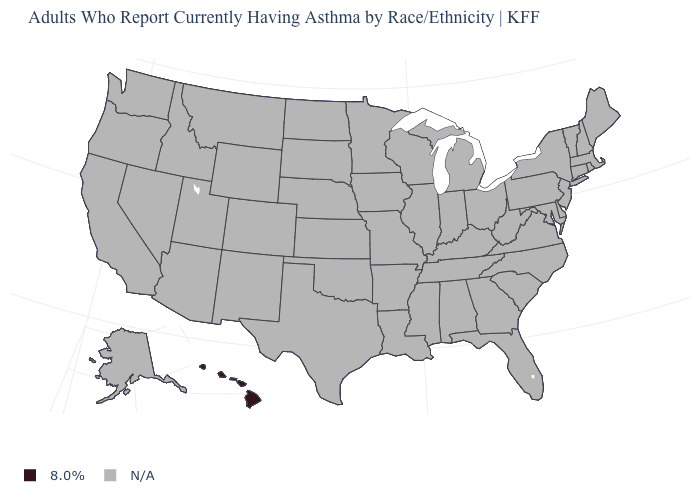How many symbols are there in the legend?
Give a very brief answer. 2. What is the value of Arkansas?
Short answer required. N/A. What is the value of Oregon?
Answer briefly. N/A. How many symbols are there in the legend?
Answer briefly. 2. How many symbols are there in the legend?
Short answer required. 2. Name the states that have a value in the range N/A?
Quick response, please. Alabama, Alaska, Arizona, Arkansas, California, Colorado, Connecticut, Delaware, Florida, Georgia, Idaho, Illinois, Indiana, Iowa, Kansas, Kentucky, Louisiana, Maine, Maryland, Massachusetts, Michigan, Minnesota, Mississippi, Missouri, Montana, Nebraska, Nevada, New Hampshire, New Jersey, New Mexico, New York, North Carolina, North Dakota, Ohio, Oklahoma, Oregon, Pennsylvania, Rhode Island, South Carolina, South Dakota, Tennessee, Texas, Utah, Vermont, Virginia, Washington, West Virginia, Wisconsin, Wyoming. Name the states that have a value in the range 8.0%?
Quick response, please. Hawaii. Name the states that have a value in the range N/A?
Keep it brief. Alabama, Alaska, Arizona, Arkansas, California, Colorado, Connecticut, Delaware, Florida, Georgia, Idaho, Illinois, Indiana, Iowa, Kansas, Kentucky, Louisiana, Maine, Maryland, Massachusetts, Michigan, Minnesota, Mississippi, Missouri, Montana, Nebraska, Nevada, New Hampshire, New Jersey, New Mexico, New York, North Carolina, North Dakota, Ohio, Oklahoma, Oregon, Pennsylvania, Rhode Island, South Carolina, South Dakota, Tennessee, Texas, Utah, Vermont, Virginia, Washington, West Virginia, Wisconsin, Wyoming. Which states have the lowest value in the USA?
Answer briefly. Hawaii. 